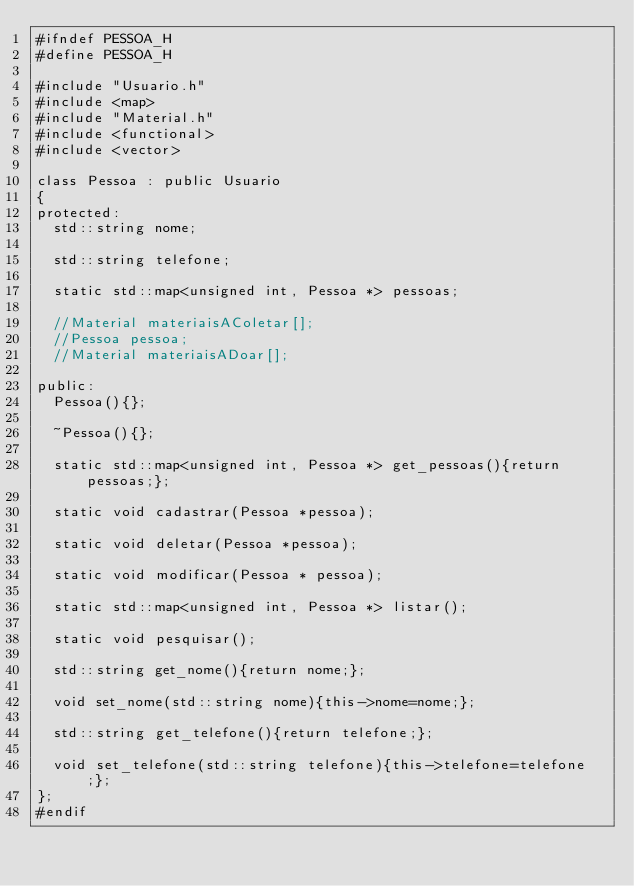<code> <loc_0><loc_0><loc_500><loc_500><_C_>#ifndef PESSOA_H
#define PESSOA_H

#include "Usuario.h"
#include <map>
#include "Material.h"
#include <functional>
#include <vector>

class Pessoa : public Usuario
{
protected:
	std::string nome;

	std::string telefone;

	static std::map<unsigned int, Pessoa *> pessoas;

	//Material materiaisAColetar[];
	//Pessoa pessoa;
	//Material materiaisADoar[];

public:
	Pessoa(){};
	
	~Pessoa(){};
	
	static std::map<unsigned int, Pessoa *> get_pessoas(){return pessoas;};

	static void cadastrar(Pessoa *pessoa);

	static void deletar(Pessoa *pessoa);

	static void modificar(Pessoa * pessoa);

	static std::map<unsigned int, Pessoa *> listar();

	static void pesquisar();
	
	std::string get_nome(){return nome;};
	
	void set_nome(std::string nome){this->nome=nome;};
	
	std::string get_telefone(){return telefone;};
	
	void set_telefone(std::string telefone){this->telefone=telefone;};
};
#endif
</code> 